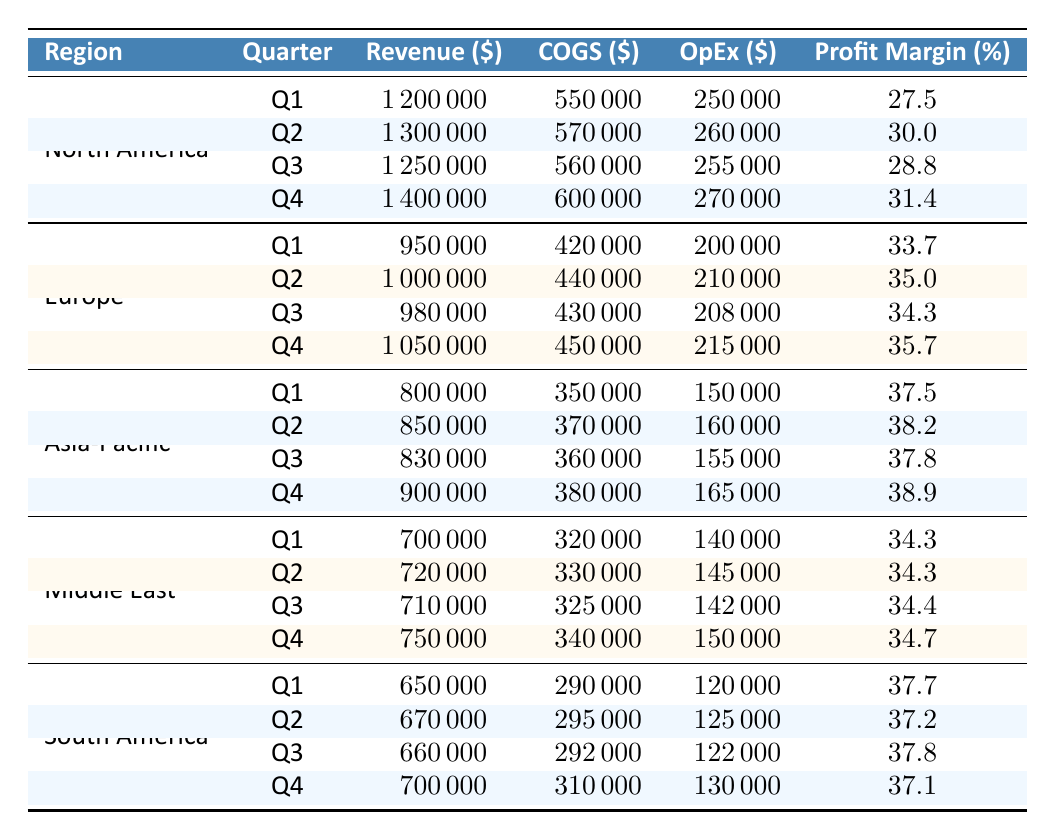What was the profit margin for Eau de Luxe in Q3? The table shows that for the North America region, the Eau de Luxe brand had a profit margin of 28.8% in Q3.
Answer: 28.8% Which region had the highest overall profit margin in Q2? By looking at the Q2 data: North America (30.0%), Europe (35.0%), Asia-Pacific (38.2%), Middle East (34.3%), and South America (37.2%), Asia-Pacific has the highest profit margin at 38.2%.
Answer: Asia-Pacific What is the total revenue for Scentual Essence across all quarters? The revenue figures for Scentual Essence are: Q1 = 950000, Q2 = 1000000, Q3 = 980000, Q4 = 1050000. Sum them up: 950000 + 1000000 + 980000 + 1050000 = 3980000.
Answer: 3980000 Is the profit margin for Arabian Nights in Q4 higher than that in Q1? In Q4, Arabian Nights had a profit margin of 34.7% while in Q1 it was 34.3%. Since 34.7% is greater than 34.3%, the statement is true.
Answer: Yes What is the average profit margin for Latin Elegance over all four quarters? The profit margins for Latin Elegance are: Q1 = 37.7%, Q2 = 37.2%, Q3 = 37.8%, Q4 = 37.1%. To find the average, calculate: (37.7 + 37.2 + 37.8 + 37.1) / 4 = 37.5%.
Answer: 37.5% Which brand consistently had the highest profit margin across all quarters? Comparing all brands: Eau de Luxe (27.5% to 31.4%), Scentual Essence (33.7% to 35.7%), Oriental Aroma (37.5% to 38.9%), Arabian Nights (34.3% to 34.7%), and Latin Elegance (37.7% to 37.1%), Oriental Aroma consistently had the highest margin from Q1 to Q4.
Answer: Oriental Aroma What was the difference in profit margin between the highest and lowest quarters for Scentual Essence? For Scentual Essence, the highest profit margin is 35.7% in Q4, and the lowest is 33.7% in Q1. The difference is 35.7% - 33.7% = 2%.
Answer: 2% In which quarter did Middle East's profit margin see the largest increase? Analyzing the profit margins for Arabian Nights in the Middle East: Q1 = 34.3%, Q2 = 34.3%, Q3 = 34.4%, Q4 = 34.7%. The increase from Q3 to Q4 was the largest, 34.4% to 34.7%.
Answer: Q3 to Q4 